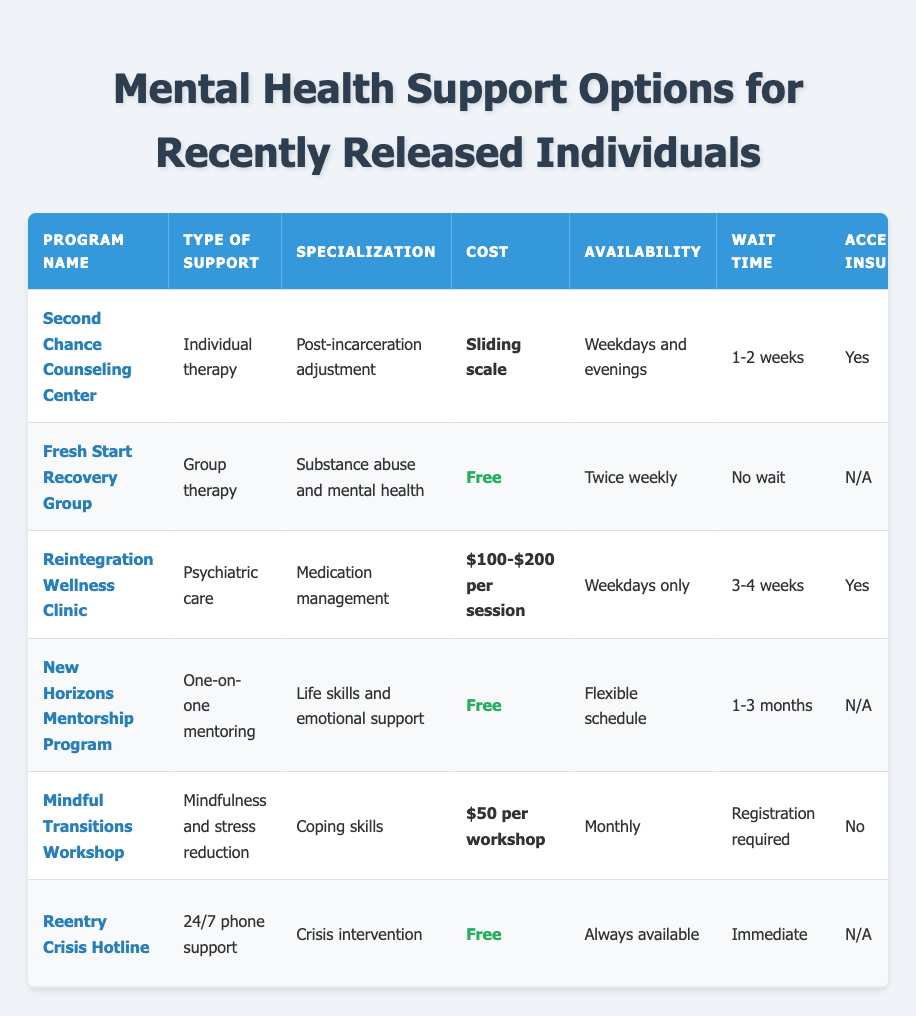What type of support does the Fresh Start Recovery Group offer? The Fresh Start Recovery Group provides group therapy as their type of support. I can find this information directly under the "Type of Support" column for this program.
Answer: Group therapy How many programs offer free support options? There are three programs listed under the "Cost" column that indicate free support: Fresh Start Recovery Group, New Horizons Mentorship Program, and Reentry Crisis Hotline. Counting these gives a total of three.
Answer: Three Which program has the longest wait time? The program with the longest wait time is the New Horizons Mentorship Program, which has a wait time of 1-3 months. This can be found by comparing the wait times for each program in the "Wait Time" column.
Answer: 1-3 months Does the Reintegration Wellness Clinic accept insurance? Yes, the Reintegration Wellness Clinic does accept insurance, as indicated in the "Accepts Insurance" column for this program.
Answer: Yes What is the average cost of the support options listed? To find the average cost, we need to consider the values of the costs that are numerical: $100-$200 (which we can average as $150), $50 (for Mindful Transitions Workshop) and the sliding scale cost is variable. For clarity, the non-numerical values (free and sliding scale) do not contribute to the average. This gives us a rough average of (150 + 50)/2 = 100.
Answer: $100 Which programs provide peer support? The programs providing peer support include Fresh Start Recovery Group, New Horizons Mentorship Program, Mindful Transitions Workshop, and Reentry Crisis Hotline. I can find this by checking the "Peer Support" column, where these programs have "Yes" listed.
Answer: Four programs How many programs are available weekdays? There are three programs available on weekdays: Second Chance Counseling Center, Reintegration Wellness Clinic, and Reintegration Crisis Hotline. This can be determined by looking at the "Availability" column and counting the programs listed as "Weekdays" or "Weekdays and evenings."
Answer: Three Is the Mindful Transitions Workshop free? No, the Mindful Transitions Workshop costs $50 per session, which can be verified in the "Cost" column for this program.
Answer: No 